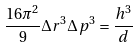<formula> <loc_0><loc_0><loc_500><loc_500>\frac { 1 6 \pi ^ { 2 } } { 9 } \Delta r ^ { 3 } \Delta p ^ { 3 } = \frac { h ^ { 3 } } { d }</formula> 